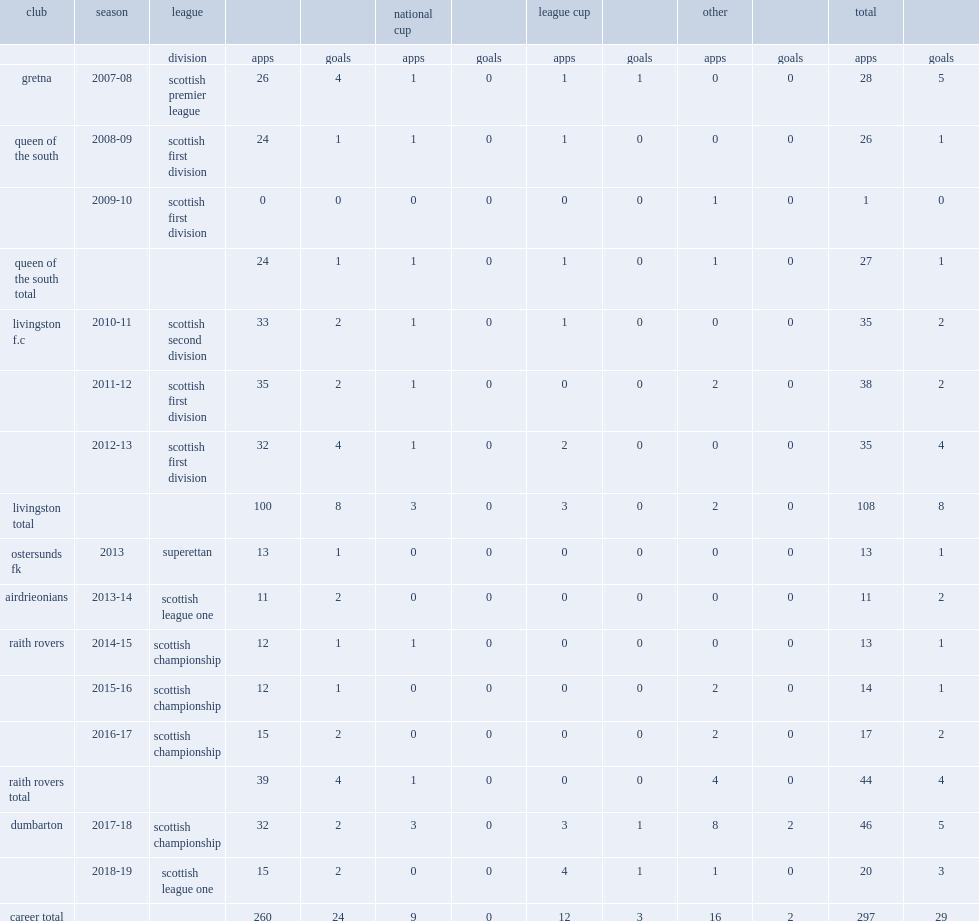In 2013,which club insuperettan did barr sign for? Ostersunds fk. 